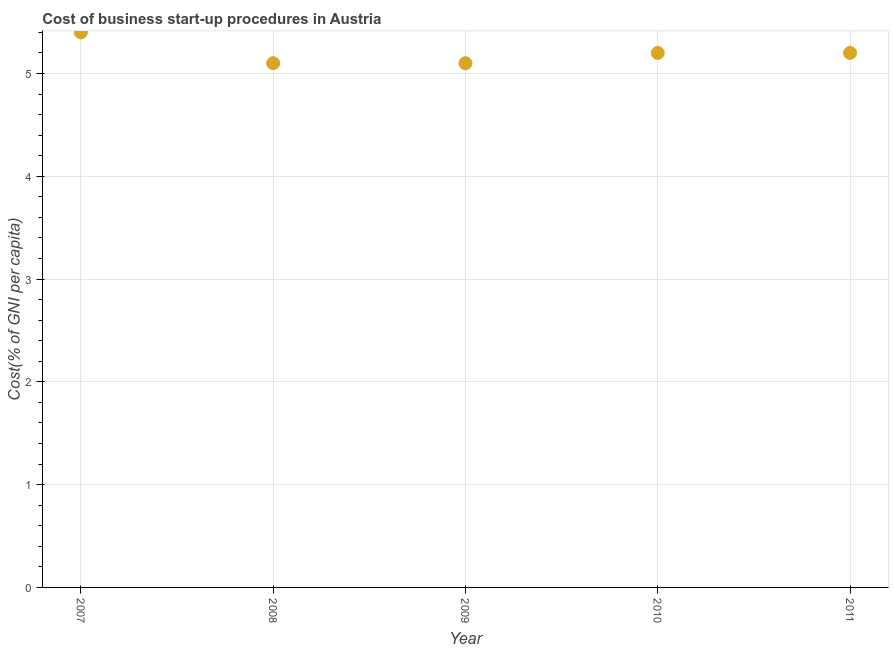What is the cost of business startup procedures in 2011?
Provide a short and direct response. 5.2. Across all years, what is the maximum cost of business startup procedures?
Keep it short and to the point. 5.4. Across all years, what is the minimum cost of business startup procedures?
Your answer should be compact. 5.1. In which year was the cost of business startup procedures maximum?
Give a very brief answer. 2007. In which year was the cost of business startup procedures minimum?
Provide a short and direct response. 2008. What is the difference between the cost of business startup procedures in 2007 and 2011?
Make the answer very short. 0.2. What is the average cost of business startup procedures per year?
Provide a short and direct response. 5.2. Do a majority of the years between 2009 and 2011 (inclusive) have cost of business startup procedures greater than 4.8 %?
Offer a very short reply. Yes. What is the ratio of the cost of business startup procedures in 2007 to that in 2010?
Offer a very short reply. 1.04. Is the cost of business startup procedures in 2008 less than that in 2009?
Provide a short and direct response. No. What is the difference between the highest and the second highest cost of business startup procedures?
Ensure brevity in your answer.  0.2. Is the sum of the cost of business startup procedures in 2008 and 2010 greater than the maximum cost of business startup procedures across all years?
Provide a succinct answer. Yes. What is the difference between the highest and the lowest cost of business startup procedures?
Offer a very short reply. 0.3. Does the cost of business startup procedures monotonically increase over the years?
Your response must be concise. No. How many dotlines are there?
Ensure brevity in your answer.  1. How many years are there in the graph?
Give a very brief answer. 5. What is the difference between two consecutive major ticks on the Y-axis?
Ensure brevity in your answer.  1. Does the graph contain any zero values?
Offer a very short reply. No. What is the title of the graph?
Make the answer very short. Cost of business start-up procedures in Austria. What is the label or title of the Y-axis?
Make the answer very short. Cost(% of GNI per capita). What is the Cost(% of GNI per capita) in 2007?
Your response must be concise. 5.4. What is the Cost(% of GNI per capita) in 2008?
Make the answer very short. 5.1. What is the difference between the Cost(% of GNI per capita) in 2007 and 2008?
Your answer should be very brief. 0.3. What is the difference between the Cost(% of GNI per capita) in 2007 and 2009?
Make the answer very short. 0.3. What is the difference between the Cost(% of GNI per capita) in 2007 and 2010?
Provide a short and direct response. 0.2. What is the difference between the Cost(% of GNI per capita) in 2007 and 2011?
Give a very brief answer. 0.2. What is the difference between the Cost(% of GNI per capita) in 2008 and 2009?
Your answer should be very brief. 0. What is the difference between the Cost(% of GNI per capita) in 2009 and 2011?
Offer a terse response. -0.1. What is the ratio of the Cost(% of GNI per capita) in 2007 to that in 2008?
Keep it short and to the point. 1.06. What is the ratio of the Cost(% of GNI per capita) in 2007 to that in 2009?
Keep it short and to the point. 1.06. What is the ratio of the Cost(% of GNI per capita) in 2007 to that in 2010?
Ensure brevity in your answer.  1.04. What is the ratio of the Cost(% of GNI per capita) in 2007 to that in 2011?
Your answer should be compact. 1.04. What is the ratio of the Cost(% of GNI per capita) in 2008 to that in 2009?
Make the answer very short. 1. What is the ratio of the Cost(% of GNI per capita) in 2008 to that in 2011?
Your answer should be compact. 0.98. What is the ratio of the Cost(% of GNI per capita) in 2009 to that in 2011?
Your response must be concise. 0.98. What is the ratio of the Cost(% of GNI per capita) in 2010 to that in 2011?
Give a very brief answer. 1. 